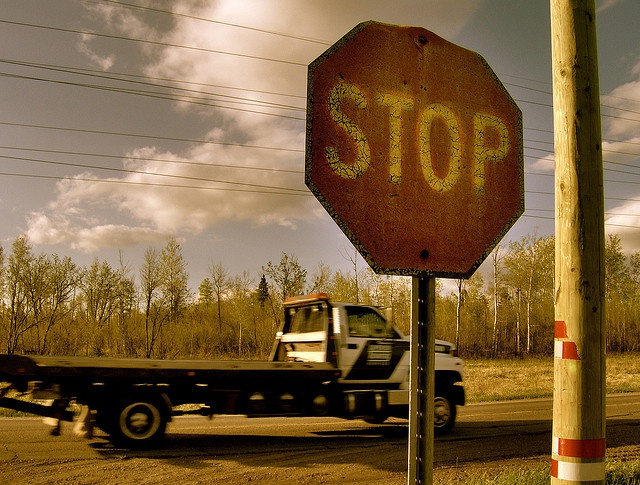Describe the objects in this image and their specific colors. I can see stop sign in gray, maroon, black, and olive tones and truck in gray, black, olive, and maroon tones in this image. 